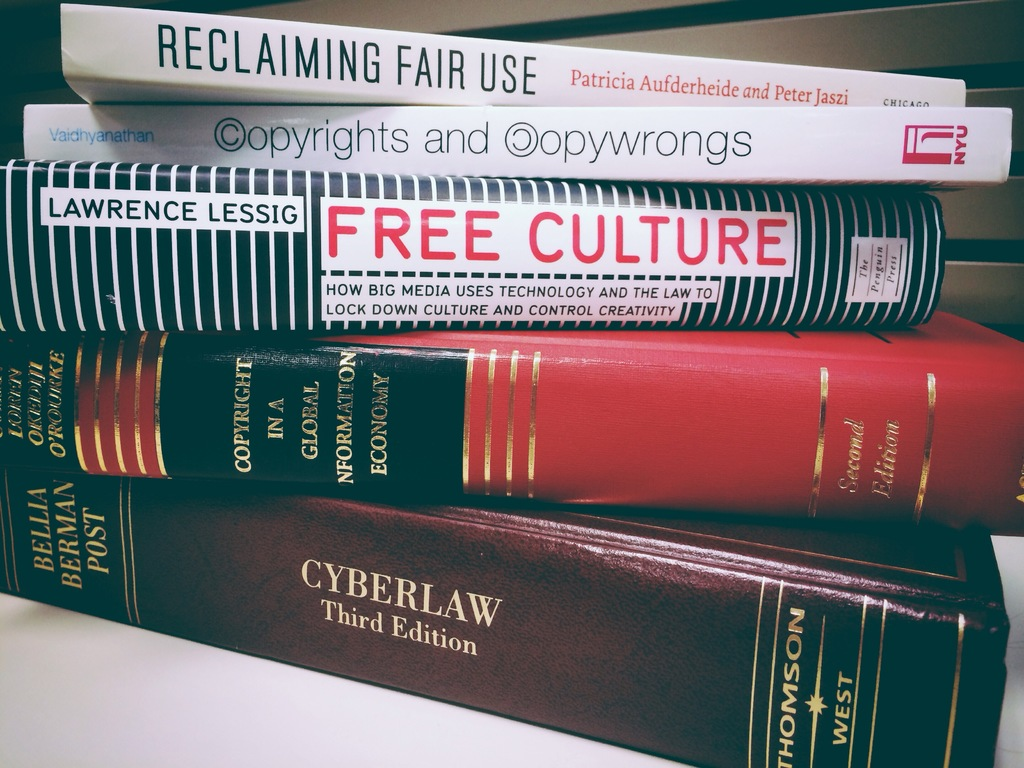What themes do these books discuss, and why might they be significant in today's digital age? These books address themes like media influence, copyright laws, technology's impact on creativity, and legal frameworks in the digital world. They are significant as they provide insight and legal perspectives on managing and protecting intellectual property in an era where digital content creation and distribution are ubiquitous. 